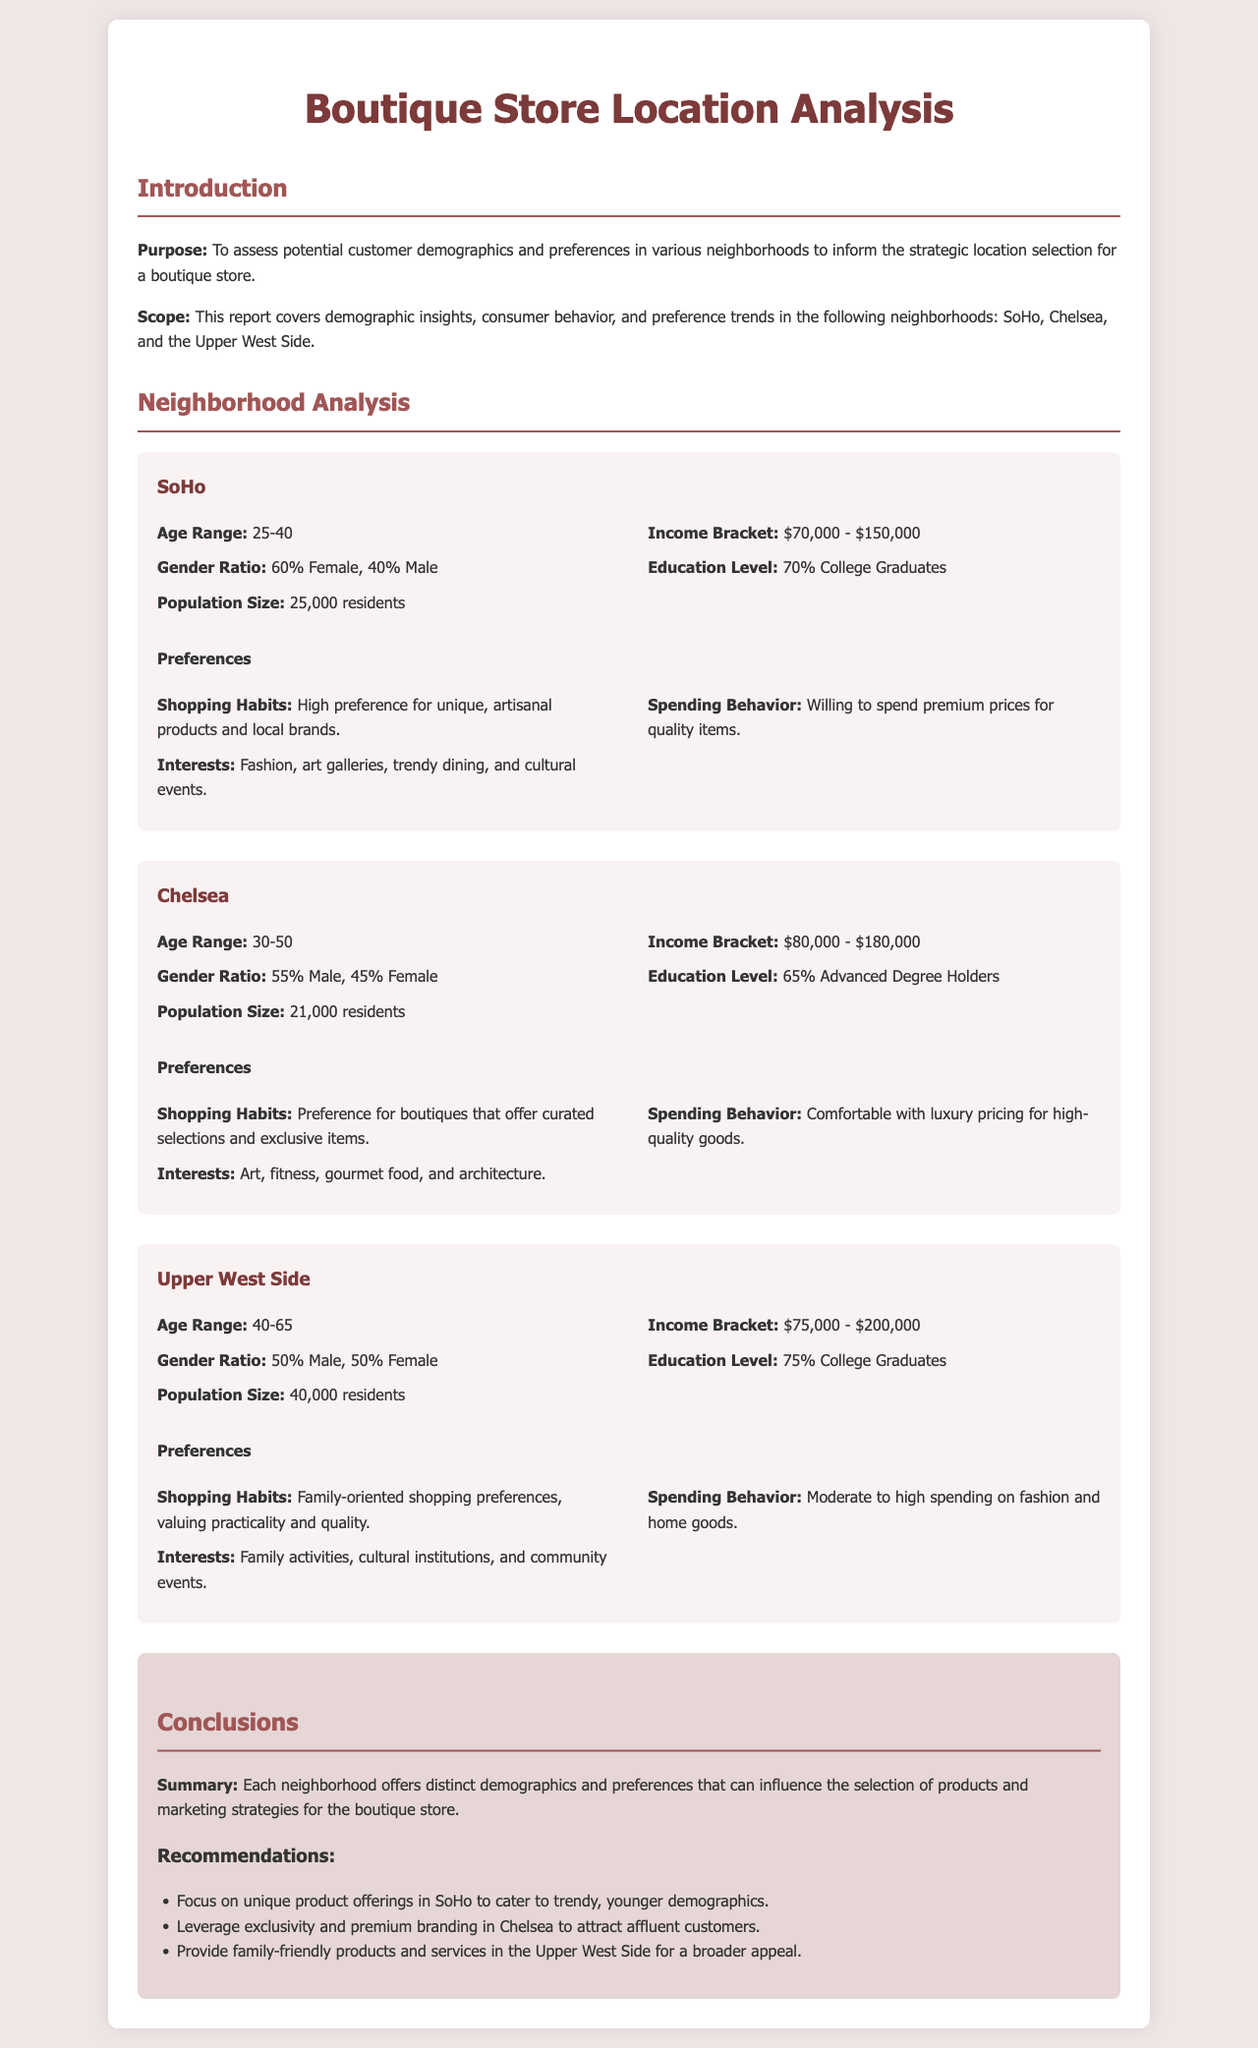What is the age range of residents in SoHo? The document states that the age range of residents in SoHo is 25-40.
Answer: 25-40 What is the income bracket for Chelsea? According to the document, the income bracket for Chelsea is $80,000 - $180,000.
Answer: $80,000 - $180,000 What percentage of Upper West Side residents are college graduates? The document mentions that 75% of Upper West Side residents are college graduates.
Answer: 75% What are the shopping habits of SoHo residents? The document describes the shopping habits of SoHo residents as having a high preference for unique, artisanal products and local brands.
Answer: Unique, artisanal products and local brands Which neighborhood has the highest population size? The document indicates that the Upper West Side has the highest population size with 40,000 residents.
Answer: 40,000 residents What is the predominant gender ratio in Chelsea? The document states that the gender ratio in Chelsea is 55% Male and 45% Female.
Answer: 55% Male, 45% Female What is the main interest of residents in the Upper West Side? The document notes that residents' main interests include family activities, cultural institutions, and community events.
Answer: Family activities, cultural institutions, and community events Which neighborhood should you focus on unique product offerings? The document recommends focusing on unique product offerings in SoHo.
Answer: SoHo 